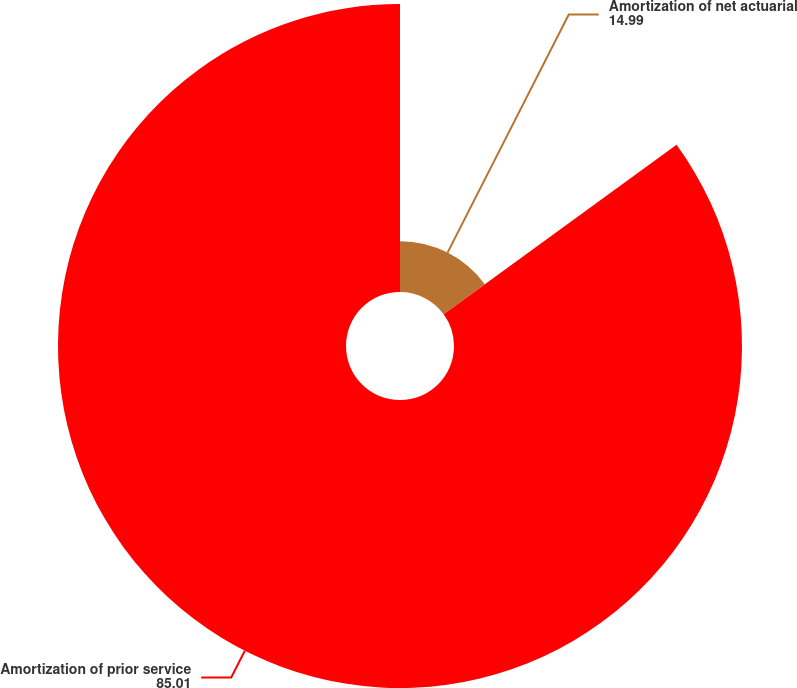<chart> <loc_0><loc_0><loc_500><loc_500><pie_chart><fcel>Amortization of net actuarial<fcel>Amortization of prior service<nl><fcel>14.99%<fcel>85.01%<nl></chart> 